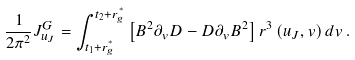Convert formula to latex. <formula><loc_0><loc_0><loc_500><loc_500>\frac { 1 } { 2 \pi ^ { 2 } } J ^ { G } _ { u _ { J } } = \int _ { t _ { 1 } + { r ^ { ^ { * } } _ { g } } } ^ { t _ { 2 } + { r ^ { ^ { * } } _ { g } } } \left [ B ^ { 2 } \partial _ { v } D - D \partial _ { v } B ^ { 2 } \right ] r ^ { 3 } \left ( u _ { J } , v \right ) d v \, .</formula> 